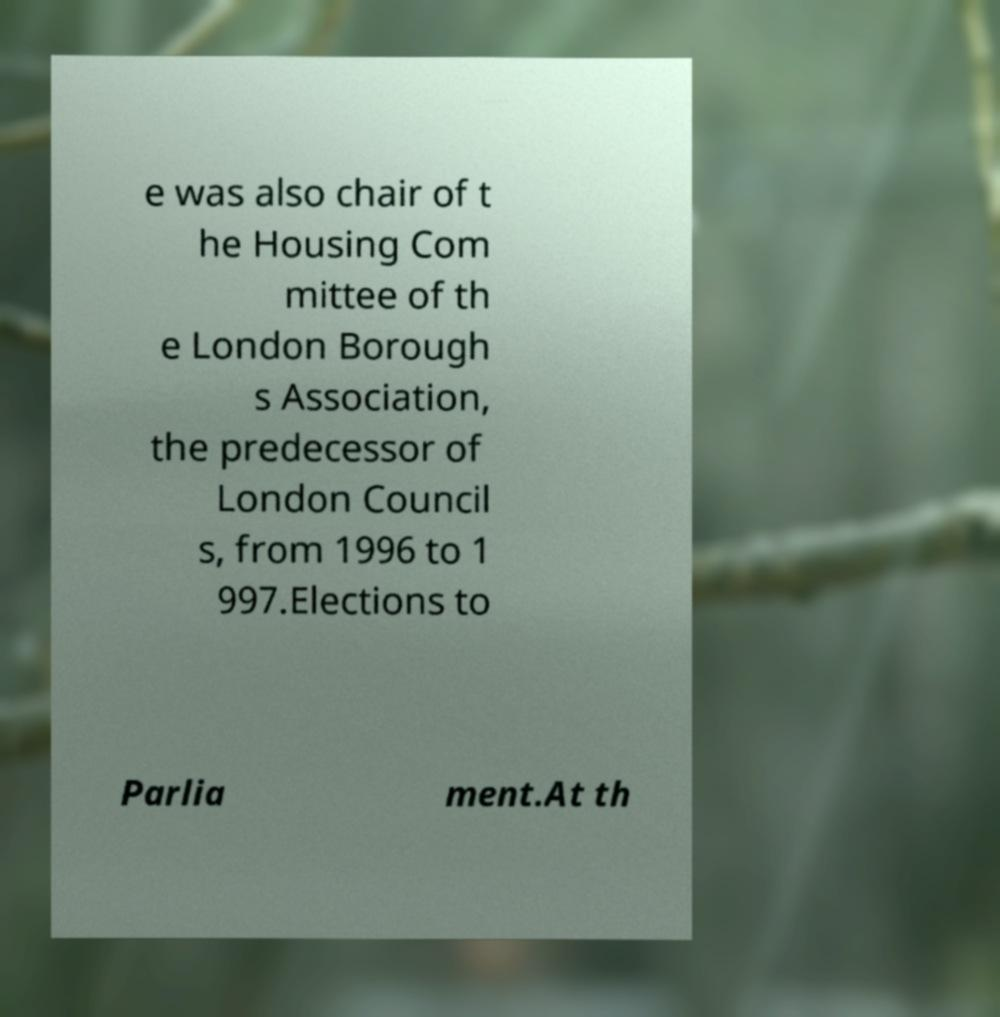Please read and relay the text visible in this image. What does it say? e was also chair of t he Housing Com mittee of th e London Borough s Association, the predecessor of London Council s, from 1996 to 1 997.Elections to Parlia ment.At th 